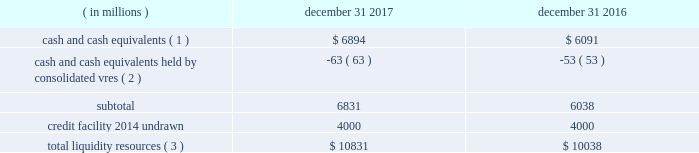Sources of blackrock 2019s operating cash primarily include investment advisory , administration fees and securities lending revenue , performance fees , revenue from technology and risk management services , advisory and other revenue and distribution fees .
Blackrock uses its cash to pay all operating expense , interest and principal on borrowings , income taxes , dividends on blackrock 2019s capital stock , repurchases of the company 2019s stock , capital expenditures and purchases of co-investments and seed investments .
For details of the company 2019s gaap cash flows from operating , investing and financing activities , see the consolidated statements of cash flows contained in part ii , item 8 of this filing .
Cash flows from operating activities , excluding the impact of consolidated sponsored investment funds , primarily include the receipt of investment advisory and administration fees , securities lending revenue and performance fees offset by the payment of operating expenses incurred in the normal course of business , including year-end incentive compensation accrued for in the prior year .
Cash outflows from investing activities , excluding the impact of consolidated sponsored investment funds , for 2017 were $ 517 million and primarily reflected $ 497 million of investment purchases , $ 155 million of purchases of property and equipment , $ 73 million related to the first reserve transaction and $ 29 million related to the cachematrix transaction , partially offset by $ 205 million of net proceeds from sales and maturities of certain investments .
Cash outflows from financing activities , excluding the impact of consolidated sponsored investment funds , for 2017 were $ 3094 million , primarily resulting from $ 1.4 billion of share repurchases , including $ 1.1 billion in open market- transactions and $ 321 million of employee tax withholdings related to employee stock transactions , $ 1.7 billion of cash dividend payments and $ 700 million of repayments of long- term borrowings , partially offset by $ 697 million of proceeds from issuance of long-term borrowings .
The company manages its financial condition and funding to maintain appropriate liquidity for the business .
Liquidity resources at december 31 , 2017 and 2016 were as follows : ( in millions ) december 31 , december 31 , cash and cash equivalents ( 1 ) $ 6894 $ 6091 cash and cash equivalents held by consolidated vres ( 2 ) ( 63 ) ( 53 ) .
Total liquidity resources ( 3 ) $ 10831 $ 10038 ( 1 ) the percentage of cash and cash equivalents held by the company 2019s u.s .
Subsidiaries was approximately 40% ( 40 % ) and 50% ( 50 % ) at december 31 , 2017 and 2016 , respectively .
See net capital requirements herein for more information on net capital requirements in certain regulated subsidiaries .
( 2 ) the company cannot readily access such cash to use in its operating activities .
( 3 ) amounts do not reflect a reduction for year-end incentive compensation accruals of approximately $ 1.5 billion and $ 1.3 billion for 2017 and 2016 , respectively , which are paid in the first quarter of the following year .
Total liquidity resources increased $ 793 million during 2017 , primarily reflecting cash flows from operating activities , partially offset by cash payments of 2016 year-end incentive awards , share repurchases of $ 1.4 billion and cash dividend payments of $ 1.7 billion .
A significant portion of the company 2019s $ 3154 million of total investments , as adjusted , is illiquid in nature and , as such , cannot be readily convertible to cash .
Share repurchases .
The company repurchased 2.6 million common shares in open market transactions under the share repurchase program for approximately $ 1.1 billion during 2017 .
At december 31 , 2017 , there were 6.4 million shares still authorized to be repurchased .
Net capital requirements .
The company is required to maintain net capital in certain regulated subsidiaries within a number of jurisdictions , which is partially maintained by retaining cash and cash equivalent investments in those subsidiaries or jurisdictions .
As a result , such subsidiaries of the company may be restricted in their ability to transfer cash between different jurisdictions and to their parents .
Additionally , transfers of cash between international jurisdictions may have adverse tax consequences that could discourage such transfers .
Blackrock institutional trust company , n.a .
( 201cbtc 201d ) is chartered as a national bank that does not accept client deposits and whose powers are limited to trust and other fiduciary activities .
Btc provides investment management services , including investment advisory and securities lending agency services , to institutional clients .
Btc is subject to regulatory capital and liquid asset requirements administered by the office of the comptroller of the currency .
At december 31 , 2017 and 2016 , the company was required to maintain approximately $ 1.8 billion and $ 1.4 billion , respectively , in net capital in certain regulated subsidiaries , including btc , entities regulated by the financial conduct authority and prudential regulation authority in the united kingdom , and the company 2019s broker-dealers .
The company was in compliance with all applicable regulatory net capital requirements .
Undistributed earnings of foreign subsidiaries .
As a result of the 2017 tax act and the one-time mandatory deemed repatriation tax on untaxed accumulated foreign earnings , a provisional amount of u.s .
Income taxes was provided on the undistributed foreign earnings .
The financial statement basis in excess of tax basis of its foreign subsidiaries remains indefinitely reinvested in foreign operations .
The company will continue to evaluate its capital management plans throughout 2018 .
Short-term borrowings 2017 revolving credit facility .
The company 2019s credit facility has an aggregate commitment amount of $ 4.0 billion and was amended in april 2017 to extend the maturity date to april 2022 ( the 201c2017 credit facility 201d ) .
The 2017 credit facility permits the company to request up to an additional $ 1.0 billion of borrowing capacity , subject to lender credit approval , increasing the overall size of the 2017 credit facility to an aggregate principal amount not to exceed $ 5.0 billion .
Interest on borrowings outstanding accrues at a rate based on the applicable london interbank offered rate plus a spread .
The 2017 credit facility requires the company .
What is the growth rate in the balance of total liquidity resources in 2017? 
Computations: ((10831 - 10038) / 10038)
Answer: 0.079. 